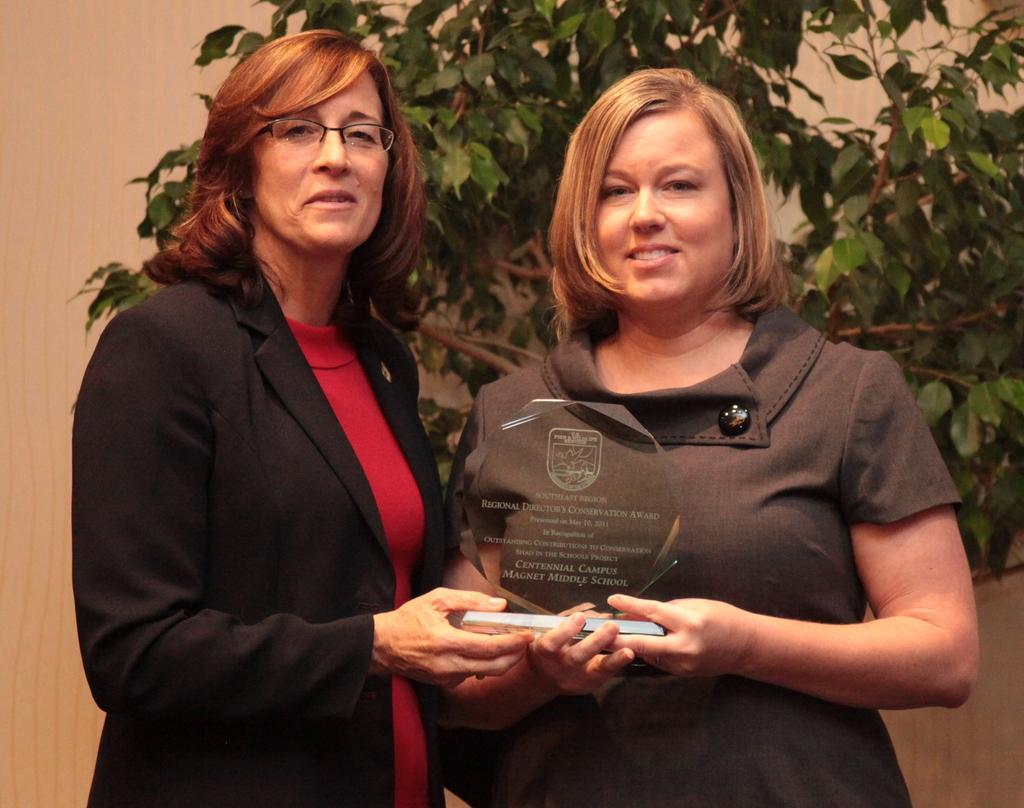How would you summarize this image in a sentence or two? As we can see in the image there is a wall, tree and two people standing in the front. 